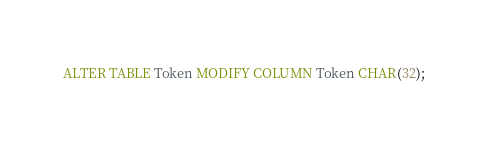<code> <loc_0><loc_0><loc_500><loc_500><_SQL_>ALTER TABLE Token MODIFY COLUMN Token CHAR(32);</code> 